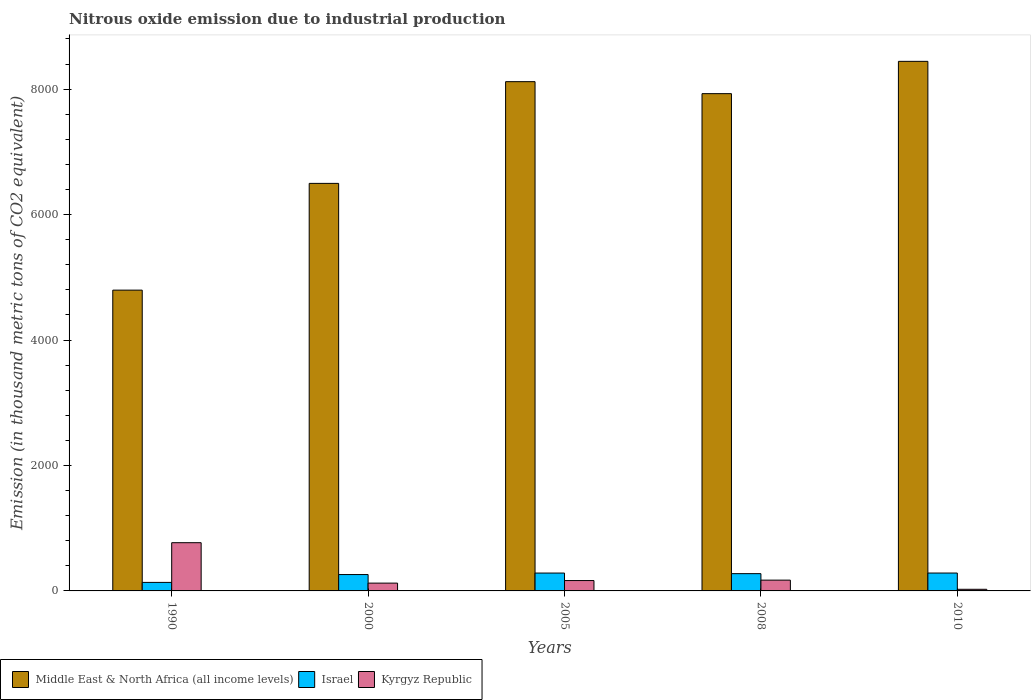Are the number of bars on each tick of the X-axis equal?
Your answer should be very brief. Yes. How many bars are there on the 2nd tick from the right?
Keep it short and to the point. 3. What is the label of the 2nd group of bars from the left?
Your answer should be compact. 2000. In how many cases, is the number of bars for a given year not equal to the number of legend labels?
Your answer should be compact. 0. What is the amount of nitrous oxide emitted in Kyrgyz Republic in 2008?
Offer a terse response. 171.9. Across all years, what is the maximum amount of nitrous oxide emitted in Israel?
Offer a very short reply. 285. Across all years, what is the minimum amount of nitrous oxide emitted in Kyrgyz Republic?
Make the answer very short. 26.1. In which year was the amount of nitrous oxide emitted in Kyrgyz Republic minimum?
Offer a very short reply. 2010. What is the total amount of nitrous oxide emitted in Israel in the graph?
Make the answer very short. 1241.9. What is the difference between the amount of nitrous oxide emitted in Middle East & North Africa (all income levels) in 1990 and that in 2008?
Your answer should be compact. -3132.5. What is the difference between the amount of nitrous oxide emitted in Kyrgyz Republic in 2008 and the amount of nitrous oxide emitted in Middle East & North Africa (all income levels) in 1990?
Provide a short and direct response. -4623.3. What is the average amount of nitrous oxide emitted in Israel per year?
Make the answer very short. 248.38. In the year 1990, what is the difference between the amount of nitrous oxide emitted in Israel and amount of nitrous oxide emitted in Kyrgyz Republic?
Provide a succinct answer. -633. What is the ratio of the amount of nitrous oxide emitted in Kyrgyz Republic in 2005 to that in 2008?
Your answer should be very brief. 0.96. Is the amount of nitrous oxide emitted in Kyrgyz Republic in 2005 less than that in 2010?
Make the answer very short. No. What is the difference between the highest and the second highest amount of nitrous oxide emitted in Israel?
Give a very brief answer. 0.1. What is the difference between the highest and the lowest amount of nitrous oxide emitted in Kyrgyz Republic?
Offer a very short reply. 742.7. What does the 3rd bar from the right in 2010 represents?
Your answer should be very brief. Middle East & North Africa (all income levels). Does the graph contain any zero values?
Ensure brevity in your answer.  No. Where does the legend appear in the graph?
Keep it short and to the point. Bottom left. What is the title of the graph?
Ensure brevity in your answer.  Nitrous oxide emission due to industrial production. Does "Cote d'Ivoire" appear as one of the legend labels in the graph?
Give a very brief answer. No. What is the label or title of the Y-axis?
Offer a terse response. Emission (in thousand metric tons of CO2 equivalent). What is the Emission (in thousand metric tons of CO2 equivalent) in Middle East & North Africa (all income levels) in 1990?
Offer a terse response. 4795.2. What is the Emission (in thousand metric tons of CO2 equivalent) in Israel in 1990?
Provide a succinct answer. 135.8. What is the Emission (in thousand metric tons of CO2 equivalent) of Kyrgyz Republic in 1990?
Provide a short and direct response. 768.8. What is the Emission (in thousand metric tons of CO2 equivalent) of Middle East & North Africa (all income levels) in 2000?
Provide a succinct answer. 6497. What is the Emission (in thousand metric tons of CO2 equivalent) in Israel in 2000?
Provide a short and direct response. 260.8. What is the Emission (in thousand metric tons of CO2 equivalent) in Kyrgyz Republic in 2000?
Offer a very short reply. 124.4. What is the Emission (in thousand metric tons of CO2 equivalent) of Middle East & North Africa (all income levels) in 2005?
Give a very brief answer. 8118.6. What is the Emission (in thousand metric tons of CO2 equivalent) of Israel in 2005?
Your answer should be compact. 284.9. What is the Emission (in thousand metric tons of CO2 equivalent) of Kyrgyz Republic in 2005?
Keep it short and to the point. 165.2. What is the Emission (in thousand metric tons of CO2 equivalent) of Middle East & North Africa (all income levels) in 2008?
Your response must be concise. 7927.7. What is the Emission (in thousand metric tons of CO2 equivalent) in Israel in 2008?
Offer a very short reply. 275.4. What is the Emission (in thousand metric tons of CO2 equivalent) in Kyrgyz Republic in 2008?
Your answer should be very brief. 171.9. What is the Emission (in thousand metric tons of CO2 equivalent) in Middle East & North Africa (all income levels) in 2010?
Ensure brevity in your answer.  8442.5. What is the Emission (in thousand metric tons of CO2 equivalent) of Israel in 2010?
Your response must be concise. 285. What is the Emission (in thousand metric tons of CO2 equivalent) in Kyrgyz Republic in 2010?
Provide a succinct answer. 26.1. Across all years, what is the maximum Emission (in thousand metric tons of CO2 equivalent) of Middle East & North Africa (all income levels)?
Your response must be concise. 8442.5. Across all years, what is the maximum Emission (in thousand metric tons of CO2 equivalent) in Israel?
Give a very brief answer. 285. Across all years, what is the maximum Emission (in thousand metric tons of CO2 equivalent) of Kyrgyz Republic?
Ensure brevity in your answer.  768.8. Across all years, what is the minimum Emission (in thousand metric tons of CO2 equivalent) of Middle East & North Africa (all income levels)?
Ensure brevity in your answer.  4795.2. Across all years, what is the minimum Emission (in thousand metric tons of CO2 equivalent) of Israel?
Ensure brevity in your answer.  135.8. Across all years, what is the minimum Emission (in thousand metric tons of CO2 equivalent) in Kyrgyz Republic?
Your answer should be compact. 26.1. What is the total Emission (in thousand metric tons of CO2 equivalent) in Middle East & North Africa (all income levels) in the graph?
Your answer should be compact. 3.58e+04. What is the total Emission (in thousand metric tons of CO2 equivalent) in Israel in the graph?
Keep it short and to the point. 1241.9. What is the total Emission (in thousand metric tons of CO2 equivalent) in Kyrgyz Republic in the graph?
Make the answer very short. 1256.4. What is the difference between the Emission (in thousand metric tons of CO2 equivalent) of Middle East & North Africa (all income levels) in 1990 and that in 2000?
Your response must be concise. -1701.8. What is the difference between the Emission (in thousand metric tons of CO2 equivalent) in Israel in 1990 and that in 2000?
Your response must be concise. -125. What is the difference between the Emission (in thousand metric tons of CO2 equivalent) in Kyrgyz Republic in 1990 and that in 2000?
Offer a very short reply. 644.4. What is the difference between the Emission (in thousand metric tons of CO2 equivalent) of Middle East & North Africa (all income levels) in 1990 and that in 2005?
Give a very brief answer. -3323.4. What is the difference between the Emission (in thousand metric tons of CO2 equivalent) of Israel in 1990 and that in 2005?
Provide a short and direct response. -149.1. What is the difference between the Emission (in thousand metric tons of CO2 equivalent) of Kyrgyz Republic in 1990 and that in 2005?
Your response must be concise. 603.6. What is the difference between the Emission (in thousand metric tons of CO2 equivalent) in Middle East & North Africa (all income levels) in 1990 and that in 2008?
Ensure brevity in your answer.  -3132.5. What is the difference between the Emission (in thousand metric tons of CO2 equivalent) in Israel in 1990 and that in 2008?
Offer a terse response. -139.6. What is the difference between the Emission (in thousand metric tons of CO2 equivalent) in Kyrgyz Republic in 1990 and that in 2008?
Offer a terse response. 596.9. What is the difference between the Emission (in thousand metric tons of CO2 equivalent) in Middle East & North Africa (all income levels) in 1990 and that in 2010?
Provide a short and direct response. -3647.3. What is the difference between the Emission (in thousand metric tons of CO2 equivalent) in Israel in 1990 and that in 2010?
Make the answer very short. -149.2. What is the difference between the Emission (in thousand metric tons of CO2 equivalent) of Kyrgyz Republic in 1990 and that in 2010?
Keep it short and to the point. 742.7. What is the difference between the Emission (in thousand metric tons of CO2 equivalent) in Middle East & North Africa (all income levels) in 2000 and that in 2005?
Offer a very short reply. -1621.6. What is the difference between the Emission (in thousand metric tons of CO2 equivalent) in Israel in 2000 and that in 2005?
Provide a succinct answer. -24.1. What is the difference between the Emission (in thousand metric tons of CO2 equivalent) of Kyrgyz Republic in 2000 and that in 2005?
Your response must be concise. -40.8. What is the difference between the Emission (in thousand metric tons of CO2 equivalent) of Middle East & North Africa (all income levels) in 2000 and that in 2008?
Offer a very short reply. -1430.7. What is the difference between the Emission (in thousand metric tons of CO2 equivalent) of Israel in 2000 and that in 2008?
Offer a very short reply. -14.6. What is the difference between the Emission (in thousand metric tons of CO2 equivalent) in Kyrgyz Republic in 2000 and that in 2008?
Keep it short and to the point. -47.5. What is the difference between the Emission (in thousand metric tons of CO2 equivalent) of Middle East & North Africa (all income levels) in 2000 and that in 2010?
Offer a very short reply. -1945.5. What is the difference between the Emission (in thousand metric tons of CO2 equivalent) of Israel in 2000 and that in 2010?
Your answer should be very brief. -24.2. What is the difference between the Emission (in thousand metric tons of CO2 equivalent) of Kyrgyz Republic in 2000 and that in 2010?
Keep it short and to the point. 98.3. What is the difference between the Emission (in thousand metric tons of CO2 equivalent) in Middle East & North Africa (all income levels) in 2005 and that in 2008?
Ensure brevity in your answer.  190.9. What is the difference between the Emission (in thousand metric tons of CO2 equivalent) of Kyrgyz Republic in 2005 and that in 2008?
Keep it short and to the point. -6.7. What is the difference between the Emission (in thousand metric tons of CO2 equivalent) in Middle East & North Africa (all income levels) in 2005 and that in 2010?
Your answer should be compact. -323.9. What is the difference between the Emission (in thousand metric tons of CO2 equivalent) of Kyrgyz Republic in 2005 and that in 2010?
Offer a very short reply. 139.1. What is the difference between the Emission (in thousand metric tons of CO2 equivalent) of Middle East & North Africa (all income levels) in 2008 and that in 2010?
Provide a succinct answer. -514.8. What is the difference between the Emission (in thousand metric tons of CO2 equivalent) of Israel in 2008 and that in 2010?
Offer a very short reply. -9.6. What is the difference between the Emission (in thousand metric tons of CO2 equivalent) in Kyrgyz Republic in 2008 and that in 2010?
Your answer should be compact. 145.8. What is the difference between the Emission (in thousand metric tons of CO2 equivalent) of Middle East & North Africa (all income levels) in 1990 and the Emission (in thousand metric tons of CO2 equivalent) of Israel in 2000?
Provide a succinct answer. 4534.4. What is the difference between the Emission (in thousand metric tons of CO2 equivalent) of Middle East & North Africa (all income levels) in 1990 and the Emission (in thousand metric tons of CO2 equivalent) of Kyrgyz Republic in 2000?
Make the answer very short. 4670.8. What is the difference between the Emission (in thousand metric tons of CO2 equivalent) of Israel in 1990 and the Emission (in thousand metric tons of CO2 equivalent) of Kyrgyz Republic in 2000?
Provide a short and direct response. 11.4. What is the difference between the Emission (in thousand metric tons of CO2 equivalent) of Middle East & North Africa (all income levels) in 1990 and the Emission (in thousand metric tons of CO2 equivalent) of Israel in 2005?
Provide a short and direct response. 4510.3. What is the difference between the Emission (in thousand metric tons of CO2 equivalent) in Middle East & North Africa (all income levels) in 1990 and the Emission (in thousand metric tons of CO2 equivalent) in Kyrgyz Republic in 2005?
Offer a very short reply. 4630. What is the difference between the Emission (in thousand metric tons of CO2 equivalent) in Israel in 1990 and the Emission (in thousand metric tons of CO2 equivalent) in Kyrgyz Republic in 2005?
Your answer should be very brief. -29.4. What is the difference between the Emission (in thousand metric tons of CO2 equivalent) in Middle East & North Africa (all income levels) in 1990 and the Emission (in thousand metric tons of CO2 equivalent) in Israel in 2008?
Make the answer very short. 4519.8. What is the difference between the Emission (in thousand metric tons of CO2 equivalent) in Middle East & North Africa (all income levels) in 1990 and the Emission (in thousand metric tons of CO2 equivalent) in Kyrgyz Republic in 2008?
Keep it short and to the point. 4623.3. What is the difference between the Emission (in thousand metric tons of CO2 equivalent) of Israel in 1990 and the Emission (in thousand metric tons of CO2 equivalent) of Kyrgyz Republic in 2008?
Provide a succinct answer. -36.1. What is the difference between the Emission (in thousand metric tons of CO2 equivalent) in Middle East & North Africa (all income levels) in 1990 and the Emission (in thousand metric tons of CO2 equivalent) in Israel in 2010?
Offer a terse response. 4510.2. What is the difference between the Emission (in thousand metric tons of CO2 equivalent) of Middle East & North Africa (all income levels) in 1990 and the Emission (in thousand metric tons of CO2 equivalent) of Kyrgyz Republic in 2010?
Provide a short and direct response. 4769.1. What is the difference between the Emission (in thousand metric tons of CO2 equivalent) in Israel in 1990 and the Emission (in thousand metric tons of CO2 equivalent) in Kyrgyz Republic in 2010?
Your response must be concise. 109.7. What is the difference between the Emission (in thousand metric tons of CO2 equivalent) in Middle East & North Africa (all income levels) in 2000 and the Emission (in thousand metric tons of CO2 equivalent) in Israel in 2005?
Give a very brief answer. 6212.1. What is the difference between the Emission (in thousand metric tons of CO2 equivalent) in Middle East & North Africa (all income levels) in 2000 and the Emission (in thousand metric tons of CO2 equivalent) in Kyrgyz Republic in 2005?
Offer a very short reply. 6331.8. What is the difference between the Emission (in thousand metric tons of CO2 equivalent) in Israel in 2000 and the Emission (in thousand metric tons of CO2 equivalent) in Kyrgyz Republic in 2005?
Offer a terse response. 95.6. What is the difference between the Emission (in thousand metric tons of CO2 equivalent) in Middle East & North Africa (all income levels) in 2000 and the Emission (in thousand metric tons of CO2 equivalent) in Israel in 2008?
Make the answer very short. 6221.6. What is the difference between the Emission (in thousand metric tons of CO2 equivalent) of Middle East & North Africa (all income levels) in 2000 and the Emission (in thousand metric tons of CO2 equivalent) of Kyrgyz Republic in 2008?
Make the answer very short. 6325.1. What is the difference between the Emission (in thousand metric tons of CO2 equivalent) in Israel in 2000 and the Emission (in thousand metric tons of CO2 equivalent) in Kyrgyz Republic in 2008?
Provide a short and direct response. 88.9. What is the difference between the Emission (in thousand metric tons of CO2 equivalent) of Middle East & North Africa (all income levels) in 2000 and the Emission (in thousand metric tons of CO2 equivalent) of Israel in 2010?
Offer a terse response. 6212. What is the difference between the Emission (in thousand metric tons of CO2 equivalent) of Middle East & North Africa (all income levels) in 2000 and the Emission (in thousand metric tons of CO2 equivalent) of Kyrgyz Republic in 2010?
Provide a short and direct response. 6470.9. What is the difference between the Emission (in thousand metric tons of CO2 equivalent) of Israel in 2000 and the Emission (in thousand metric tons of CO2 equivalent) of Kyrgyz Republic in 2010?
Give a very brief answer. 234.7. What is the difference between the Emission (in thousand metric tons of CO2 equivalent) of Middle East & North Africa (all income levels) in 2005 and the Emission (in thousand metric tons of CO2 equivalent) of Israel in 2008?
Give a very brief answer. 7843.2. What is the difference between the Emission (in thousand metric tons of CO2 equivalent) in Middle East & North Africa (all income levels) in 2005 and the Emission (in thousand metric tons of CO2 equivalent) in Kyrgyz Republic in 2008?
Keep it short and to the point. 7946.7. What is the difference between the Emission (in thousand metric tons of CO2 equivalent) of Israel in 2005 and the Emission (in thousand metric tons of CO2 equivalent) of Kyrgyz Republic in 2008?
Ensure brevity in your answer.  113. What is the difference between the Emission (in thousand metric tons of CO2 equivalent) of Middle East & North Africa (all income levels) in 2005 and the Emission (in thousand metric tons of CO2 equivalent) of Israel in 2010?
Your answer should be compact. 7833.6. What is the difference between the Emission (in thousand metric tons of CO2 equivalent) of Middle East & North Africa (all income levels) in 2005 and the Emission (in thousand metric tons of CO2 equivalent) of Kyrgyz Republic in 2010?
Make the answer very short. 8092.5. What is the difference between the Emission (in thousand metric tons of CO2 equivalent) in Israel in 2005 and the Emission (in thousand metric tons of CO2 equivalent) in Kyrgyz Republic in 2010?
Your answer should be compact. 258.8. What is the difference between the Emission (in thousand metric tons of CO2 equivalent) in Middle East & North Africa (all income levels) in 2008 and the Emission (in thousand metric tons of CO2 equivalent) in Israel in 2010?
Ensure brevity in your answer.  7642.7. What is the difference between the Emission (in thousand metric tons of CO2 equivalent) of Middle East & North Africa (all income levels) in 2008 and the Emission (in thousand metric tons of CO2 equivalent) of Kyrgyz Republic in 2010?
Your answer should be very brief. 7901.6. What is the difference between the Emission (in thousand metric tons of CO2 equivalent) in Israel in 2008 and the Emission (in thousand metric tons of CO2 equivalent) in Kyrgyz Republic in 2010?
Ensure brevity in your answer.  249.3. What is the average Emission (in thousand metric tons of CO2 equivalent) in Middle East & North Africa (all income levels) per year?
Your answer should be compact. 7156.2. What is the average Emission (in thousand metric tons of CO2 equivalent) of Israel per year?
Offer a very short reply. 248.38. What is the average Emission (in thousand metric tons of CO2 equivalent) of Kyrgyz Republic per year?
Provide a succinct answer. 251.28. In the year 1990, what is the difference between the Emission (in thousand metric tons of CO2 equivalent) of Middle East & North Africa (all income levels) and Emission (in thousand metric tons of CO2 equivalent) of Israel?
Your answer should be very brief. 4659.4. In the year 1990, what is the difference between the Emission (in thousand metric tons of CO2 equivalent) in Middle East & North Africa (all income levels) and Emission (in thousand metric tons of CO2 equivalent) in Kyrgyz Republic?
Provide a succinct answer. 4026.4. In the year 1990, what is the difference between the Emission (in thousand metric tons of CO2 equivalent) of Israel and Emission (in thousand metric tons of CO2 equivalent) of Kyrgyz Republic?
Your response must be concise. -633. In the year 2000, what is the difference between the Emission (in thousand metric tons of CO2 equivalent) in Middle East & North Africa (all income levels) and Emission (in thousand metric tons of CO2 equivalent) in Israel?
Ensure brevity in your answer.  6236.2. In the year 2000, what is the difference between the Emission (in thousand metric tons of CO2 equivalent) of Middle East & North Africa (all income levels) and Emission (in thousand metric tons of CO2 equivalent) of Kyrgyz Republic?
Your answer should be compact. 6372.6. In the year 2000, what is the difference between the Emission (in thousand metric tons of CO2 equivalent) in Israel and Emission (in thousand metric tons of CO2 equivalent) in Kyrgyz Republic?
Your answer should be compact. 136.4. In the year 2005, what is the difference between the Emission (in thousand metric tons of CO2 equivalent) in Middle East & North Africa (all income levels) and Emission (in thousand metric tons of CO2 equivalent) in Israel?
Keep it short and to the point. 7833.7. In the year 2005, what is the difference between the Emission (in thousand metric tons of CO2 equivalent) in Middle East & North Africa (all income levels) and Emission (in thousand metric tons of CO2 equivalent) in Kyrgyz Republic?
Your answer should be compact. 7953.4. In the year 2005, what is the difference between the Emission (in thousand metric tons of CO2 equivalent) in Israel and Emission (in thousand metric tons of CO2 equivalent) in Kyrgyz Republic?
Your answer should be very brief. 119.7. In the year 2008, what is the difference between the Emission (in thousand metric tons of CO2 equivalent) in Middle East & North Africa (all income levels) and Emission (in thousand metric tons of CO2 equivalent) in Israel?
Your answer should be compact. 7652.3. In the year 2008, what is the difference between the Emission (in thousand metric tons of CO2 equivalent) in Middle East & North Africa (all income levels) and Emission (in thousand metric tons of CO2 equivalent) in Kyrgyz Republic?
Offer a very short reply. 7755.8. In the year 2008, what is the difference between the Emission (in thousand metric tons of CO2 equivalent) of Israel and Emission (in thousand metric tons of CO2 equivalent) of Kyrgyz Republic?
Offer a terse response. 103.5. In the year 2010, what is the difference between the Emission (in thousand metric tons of CO2 equivalent) in Middle East & North Africa (all income levels) and Emission (in thousand metric tons of CO2 equivalent) in Israel?
Make the answer very short. 8157.5. In the year 2010, what is the difference between the Emission (in thousand metric tons of CO2 equivalent) in Middle East & North Africa (all income levels) and Emission (in thousand metric tons of CO2 equivalent) in Kyrgyz Republic?
Provide a succinct answer. 8416.4. In the year 2010, what is the difference between the Emission (in thousand metric tons of CO2 equivalent) of Israel and Emission (in thousand metric tons of CO2 equivalent) of Kyrgyz Republic?
Ensure brevity in your answer.  258.9. What is the ratio of the Emission (in thousand metric tons of CO2 equivalent) of Middle East & North Africa (all income levels) in 1990 to that in 2000?
Provide a short and direct response. 0.74. What is the ratio of the Emission (in thousand metric tons of CO2 equivalent) of Israel in 1990 to that in 2000?
Your answer should be very brief. 0.52. What is the ratio of the Emission (in thousand metric tons of CO2 equivalent) of Kyrgyz Republic in 1990 to that in 2000?
Offer a terse response. 6.18. What is the ratio of the Emission (in thousand metric tons of CO2 equivalent) of Middle East & North Africa (all income levels) in 1990 to that in 2005?
Give a very brief answer. 0.59. What is the ratio of the Emission (in thousand metric tons of CO2 equivalent) in Israel in 1990 to that in 2005?
Your answer should be compact. 0.48. What is the ratio of the Emission (in thousand metric tons of CO2 equivalent) of Kyrgyz Republic in 1990 to that in 2005?
Give a very brief answer. 4.65. What is the ratio of the Emission (in thousand metric tons of CO2 equivalent) of Middle East & North Africa (all income levels) in 1990 to that in 2008?
Keep it short and to the point. 0.6. What is the ratio of the Emission (in thousand metric tons of CO2 equivalent) of Israel in 1990 to that in 2008?
Keep it short and to the point. 0.49. What is the ratio of the Emission (in thousand metric tons of CO2 equivalent) in Kyrgyz Republic in 1990 to that in 2008?
Offer a very short reply. 4.47. What is the ratio of the Emission (in thousand metric tons of CO2 equivalent) in Middle East & North Africa (all income levels) in 1990 to that in 2010?
Your response must be concise. 0.57. What is the ratio of the Emission (in thousand metric tons of CO2 equivalent) of Israel in 1990 to that in 2010?
Keep it short and to the point. 0.48. What is the ratio of the Emission (in thousand metric tons of CO2 equivalent) in Kyrgyz Republic in 1990 to that in 2010?
Ensure brevity in your answer.  29.46. What is the ratio of the Emission (in thousand metric tons of CO2 equivalent) of Middle East & North Africa (all income levels) in 2000 to that in 2005?
Your answer should be compact. 0.8. What is the ratio of the Emission (in thousand metric tons of CO2 equivalent) in Israel in 2000 to that in 2005?
Your answer should be compact. 0.92. What is the ratio of the Emission (in thousand metric tons of CO2 equivalent) in Kyrgyz Republic in 2000 to that in 2005?
Give a very brief answer. 0.75. What is the ratio of the Emission (in thousand metric tons of CO2 equivalent) in Middle East & North Africa (all income levels) in 2000 to that in 2008?
Ensure brevity in your answer.  0.82. What is the ratio of the Emission (in thousand metric tons of CO2 equivalent) of Israel in 2000 to that in 2008?
Offer a terse response. 0.95. What is the ratio of the Emission (in thousand metric tons of CO2 equivalent) in Kyrgyz Republic in 2000 to that in 2008?
Offer a terse response. 0.72. What is the ratio of the Emission (in thousand metric tons of CO2 equivalent) of Middle East & North Africa (all income levels) in 2000 to that in 2010?
Offer a terse response. 0.77. What is the ratio of the Emission (in thousand metric tons of CO2 equivalent) of Israel in 2000 to that in 2010?
Your answer should be compact. 0.92. What is the ratio of the Emission (in thousand metric tons of CO2 equivalent) of Kyrgyz Republic in 2000 to that in 2010?
Give a very brief answer. 4.77. What is the ratio of the Emission (in thousand metric tons of CO2 equivalent) of Middle East & North Africa (all income levels) in 2005 to that in 2008?
Ensure brevity in your answer.  1.02. What is the ratio of the Emission (in thousand metric tons of CO2 equivalent) in Israel in 2005 to that in 2008?
Your answer should be compact. 1.03. What is the ratio of the Emission (in thousand metric tons of CO2 equivalent) in Kyrgyz Republic in 2005 to that in 2008?
Your answer should be compact. 0.96. What is the ratio of the Emission (in thousand metric tons of CO2 equivalent) in Middle East & North Africa (all income levels) in 2005 to that in 2010?
Provide a short and direct response. 0.96. What is the ratio of the Emission (in thousand metric tons of CO2 equivalent) of Kyrgyz Republic in 2005 to that in 2010?
Offer a very short reply. 6.33. What is the ratio of the Emission (in thousand metric tons of CO2 equivalent) of Middle East & North Africa (all income levels) in 2008 to that in 2010?
Provide a short and direct response. 0.94. What is the ratio of the Emission (in thousand metric tons of CO2 equivalent) in Israel in 2008 to that in 2010?
Provide a short and direct response. 0.97. What is the ratio of the Emission (in thousand metric tons of CO2 equivalent) of Kyrgyz Republic in 2008 to that in 2010?
Your answer should be very brief. 6.59. What is the difference between the highest and the second highest Emission (in thousand metric tons of CO2 equivalent) of Middle East & North Africa (all income levels)?
Offer a terse response. 323.9. What is the difference between the highest and the second highest Emission (in thousand metric tons of CO2 equivalent) in Kyrgyz Republic?
Your answer should be very brief. 596.9. What is the difference between the highest and the lowest Emission (in thousand metric tons of CO2 equivalent) in Middle East & North Africa (all income levels)?
Your answer should be compact. 3647.3. What is the difference between the highest and the lowest Emission (in thousand metric tons of CO2 equivalent) in Israel?
Your answer should be compact. 149.2. What is the difference between the highest and the lowest Emission (in thousand metric tons of CO2 equivalent) in Kyrgyz Republic?
Your answer should be compact. 742.7. 